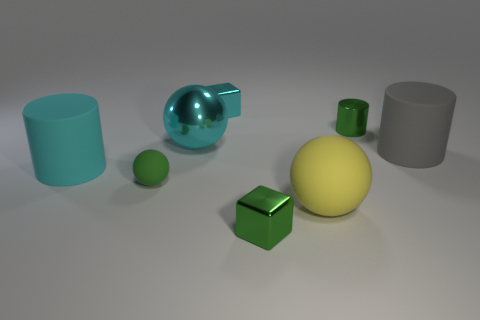Are there any gray objects to the left of the tiny green matte thing?
Your answer should be very brief. No. Is the number of yellow rubber spheres behind the tiny green cylinder the same as the number of green cubes on the left side of the cyan ball?
Make the answer very short. Yes. Does the green shiny thing on the left side of the large yellow matte object have the same size as the green metal object that is behind the cyan rubber cylinder?
Ensure brevity in your answer.  Yes. The green metal object in front of the large rubber cylinder on the right side of the big sphere that is behind the big yellow object is what shape?
Make the answer very short. Cube. Is there anything else that has the same material as the green block?
Offer a very short reply. Yes. There is a cyan object that is the same shape as the tiny green matte thing; what size is it?
Ensure brevity in your answer.  Large. There is a rubber object that is to the left of the large rubber ball and behind the small ball; what color is it?
Offer a terse response. Cyan. Is the gray object made of the same material as the small object that is in front of the small sphere?
Provide a succinct answer. No. Are there fewer metal objects to the left of the cyan rubber cylinder than large red rubber cylinders?
Your response must be concise. No. How many other objects are the same shape as the yellow rubber thing?
Your answer should be compact. 2. 